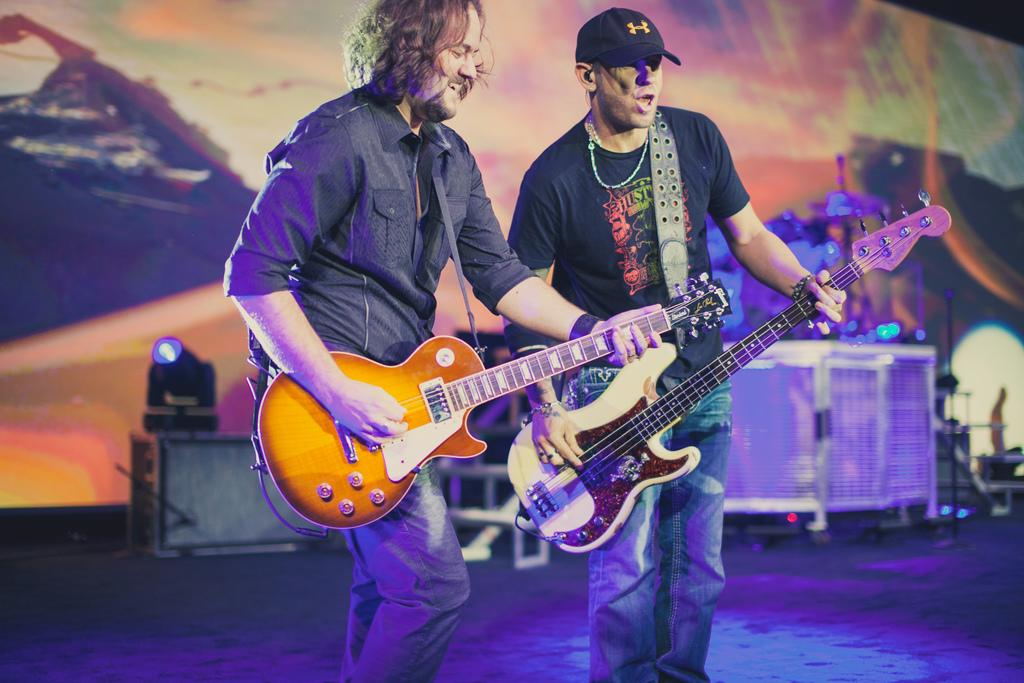How many people are in the image? There are two men in the image. What are the men doing in the image? The men are playing a guitar. Can you describe the lighting in the image? There is a light in the background of the image. What type of brush is being used by the men to play the guitar in the image? The men are not using a brush to play the guitar in the image; they are using their hands or fingers. 